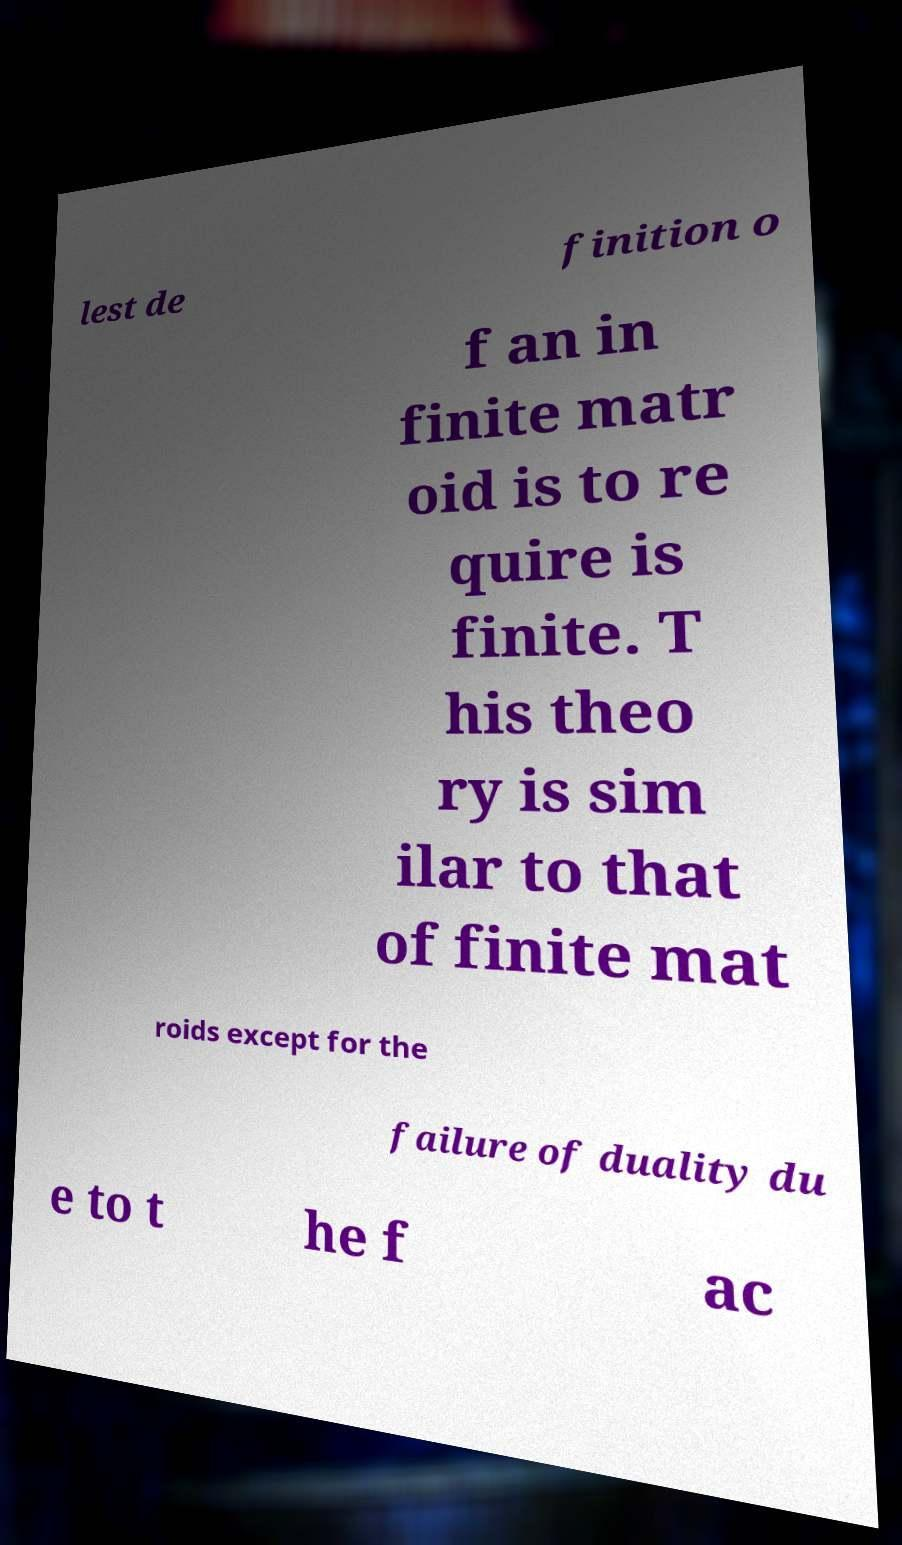For documentation purposes, I need the text within this image transcribed. Could you provide that? lest de finition o f an in finite matr oid is to re quire is finite. T his theo ry is sim ilar to that of finite mat roids except for the failure of duality du e to t he f ac 